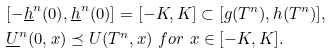Convert formula to latex. <formula><loc_0><loc_0><loc_500><loc_500>& [ - \underline { h } ^ { n } ( 0 ) , \underline { h } ^ { n } ( 0 ) ] = [ - K , K ] \subset [ g ( T ^ { n } ) , h ( T ^ { n } ) ] , \\ & \underline { U } ^ { n } ( 0 , x ) \preceq U ( T ^ { n } , x ) \ f o r \ x \in [ - K , K ] .</formula> 